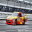The given image can contain different types of transport vehicles. People use these vehicles to travel around in their day-to-day lives. It could be air travel or a slower means of transport on the ground. Please identify the type of transport option in the picture. The type of transport option depicted in the picture is a race car, specifically designed for motorsport rather than day-to-day travel. This vehicle is used in professional racing competitions and is not suitable for regular road use due to its specialized design, which includes a powerful engine, high-performance tires, and aerodynamic bodywork for maximum speed and handling on race tracks. Race cars are built to strict safety standards to protect drivers at high speeds but are not practical for air travel or conventional ground transport needs like commuting or leisurely travel. They are a distinct category of vehicle with a purpose that is entertainment and sport-focused rather than transportation-focused in the traditional sense. 